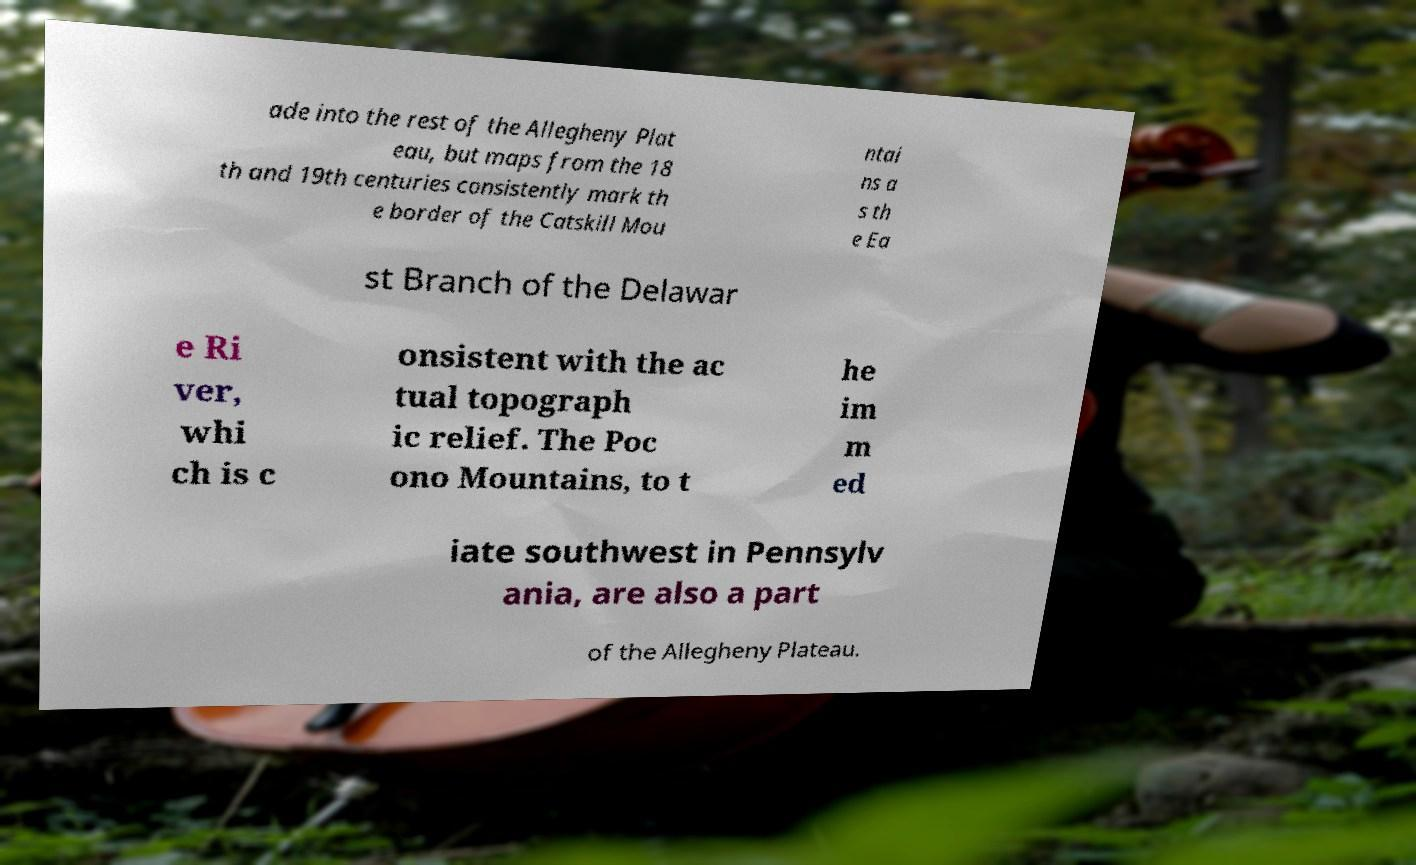Please read and relay the text visible in this image. What does it say? ade into the rest of the Allegheny Plat eau, but maps from the 18 th and 19th centuries consistently mark th e border of the Catskill Mou ntai ns a s th e Ea st Branch of the Delawar e Ri ver, whi ch is c onsistent with the ac tual topograph ic relief. The Poc ono Mountains, to t he im m ed iate southwest in Pennsylv ania, are also a part of the Allegheny Plateau. 